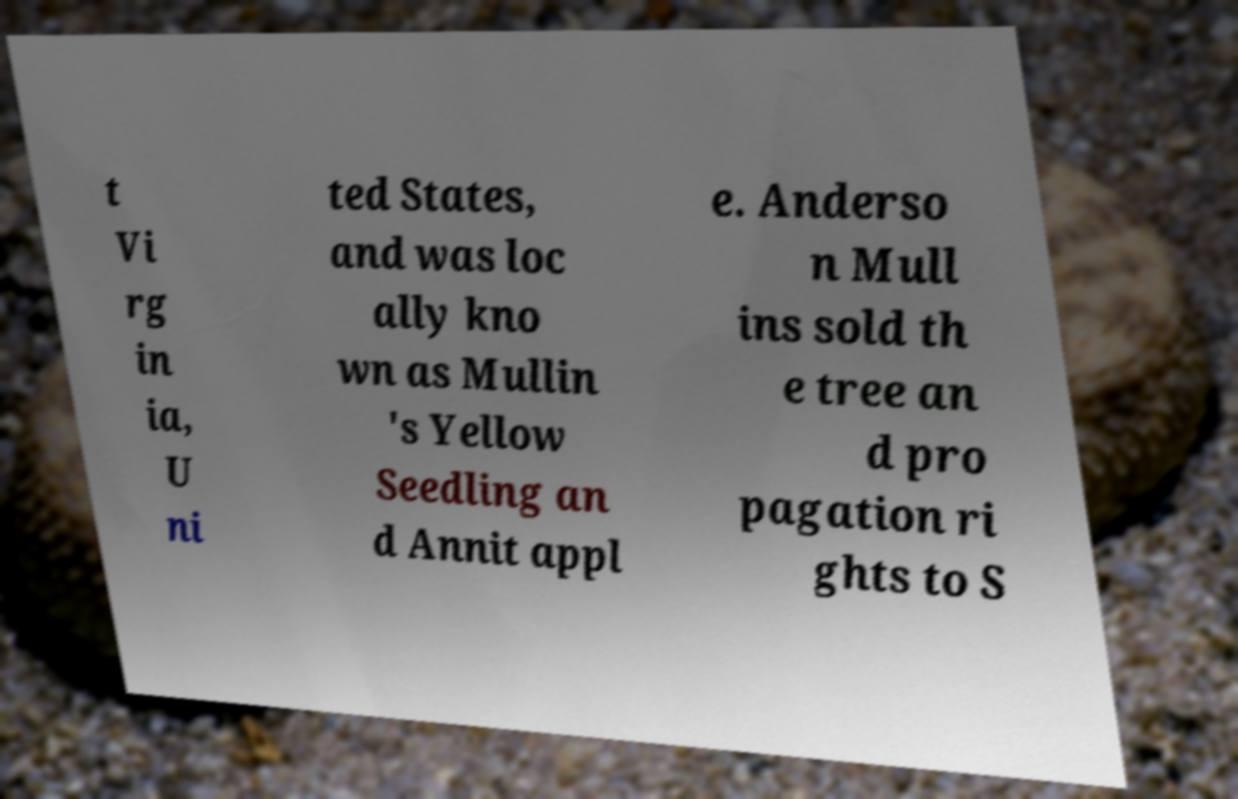There's text embedded in this image that I need extracted. Can you transcribe it verbatim? t Vi rg in ia, U ni ted States, and was loc ally kno wn as Mullin 's Yellow Seedling an d Annit appl e. Anderso n Mull ins sold th e tree an d pro pagation ri ghts to S 